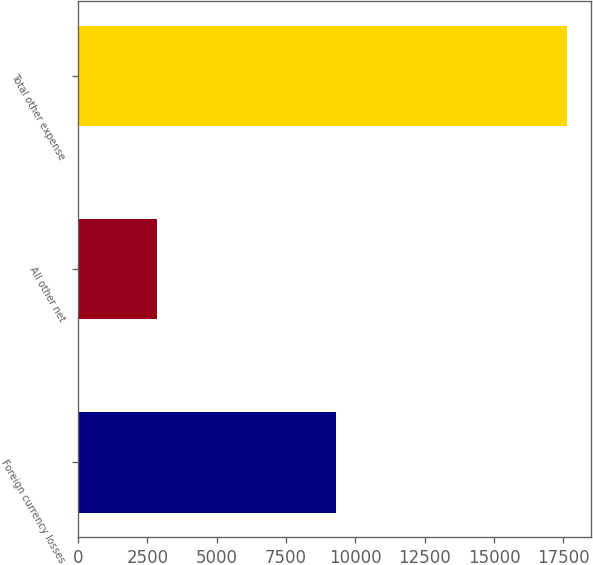<chart> <loc_0><loc_0><loc_500><loc_500><bar_chart><fcel>Foreign currency losses<fcel>All other net<fcel>Total other expense<nl><fcel>9295<fcel>2856<fcel>17619<nl></chart> 